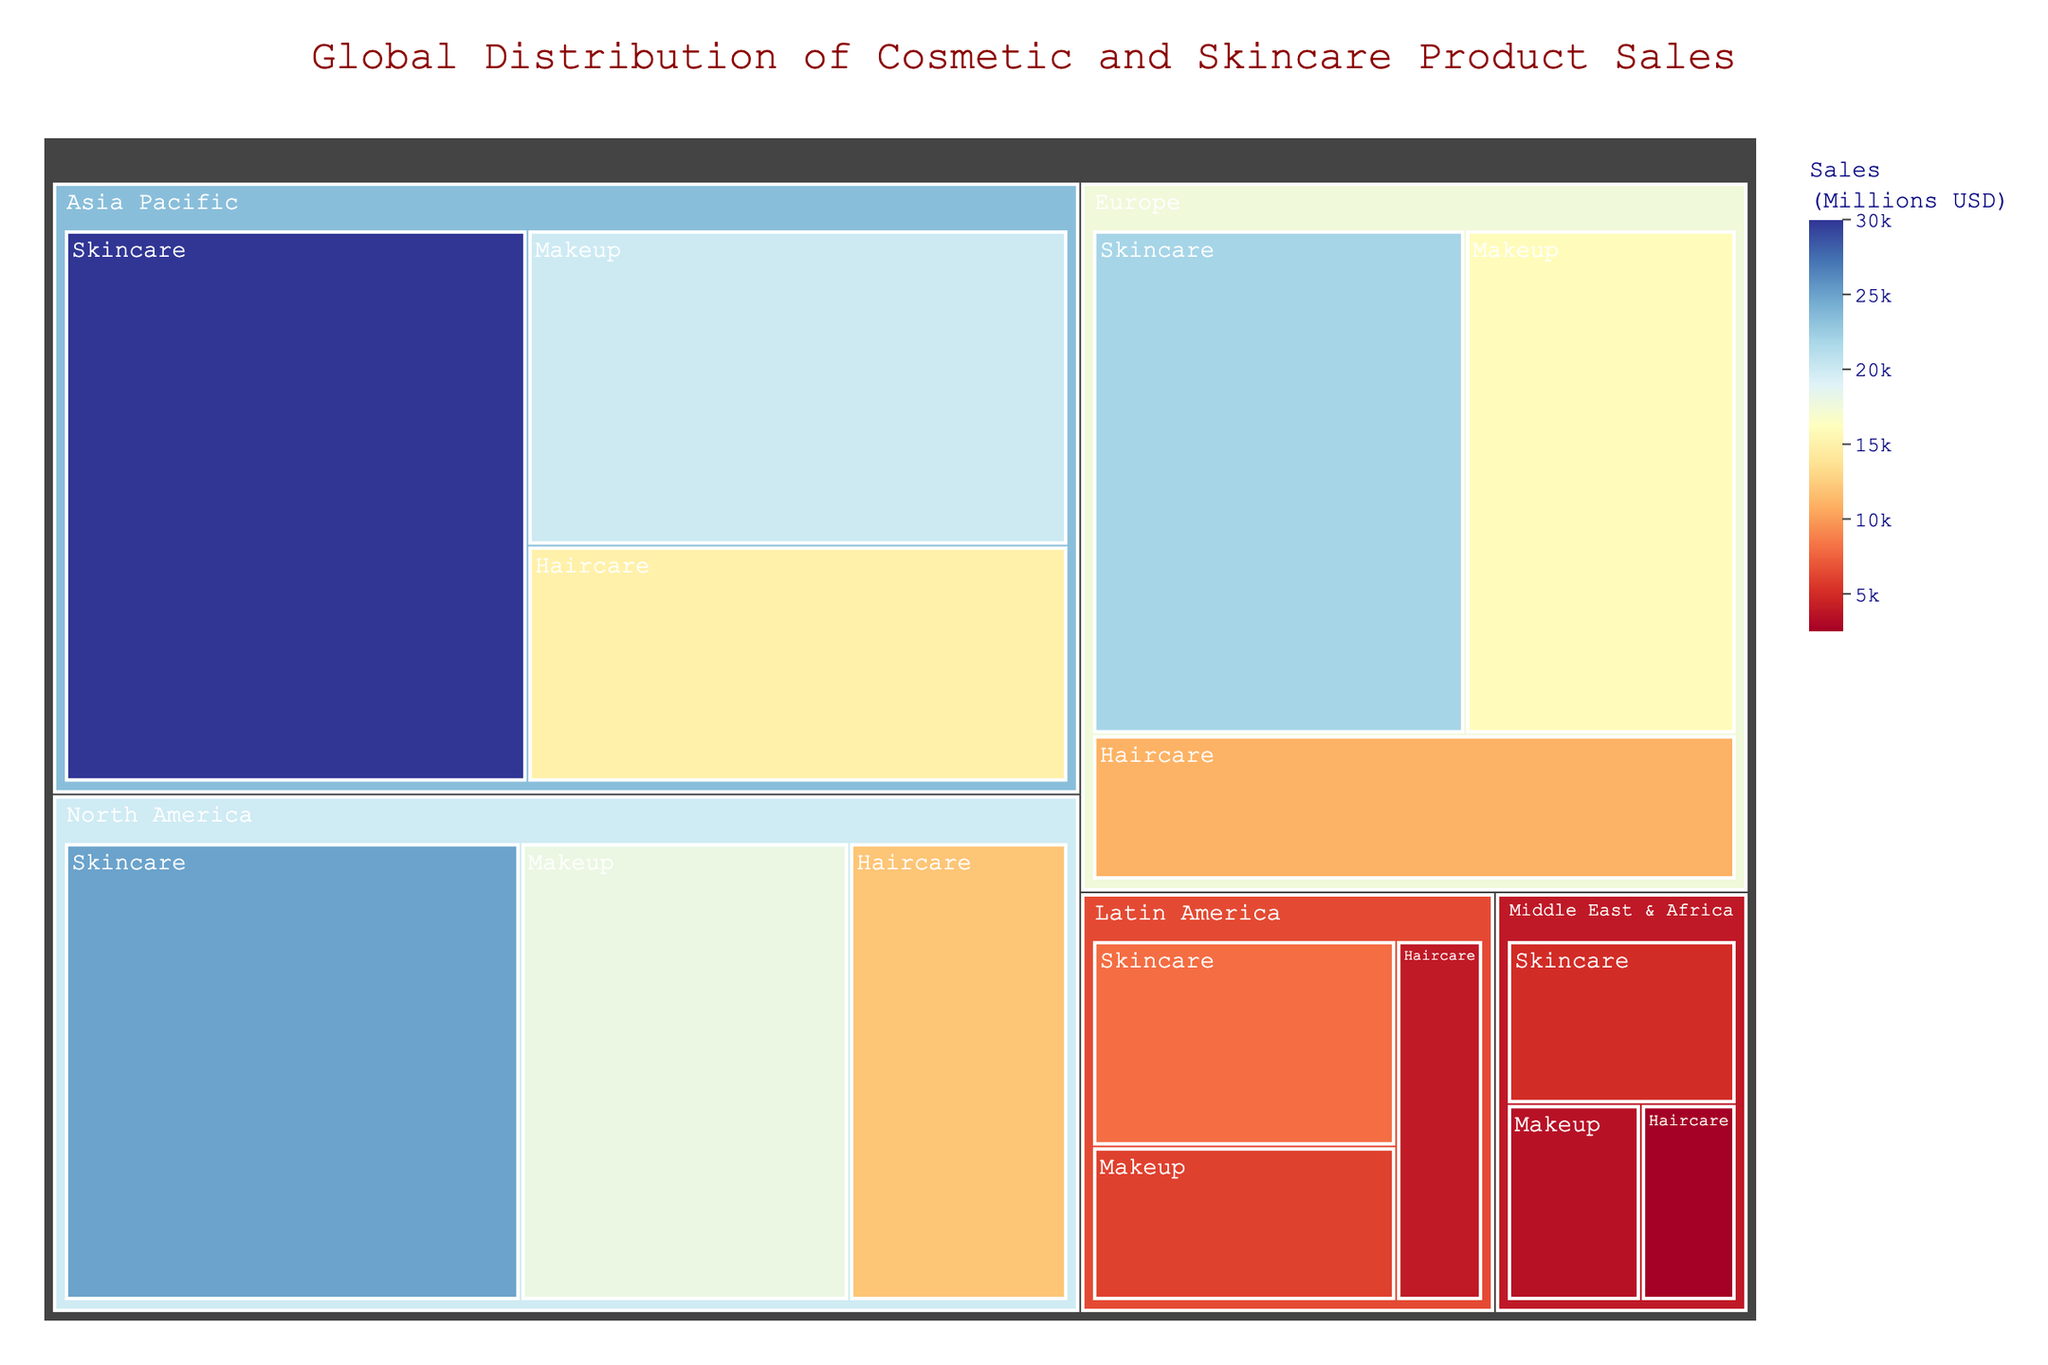Which product type has the highest sales in North America? By examining the treemap, locate the region for "North America" and then identify the product type with the largest proportion. "Skincare" occupies the largest portion, indicating it has the highest sales in North America.
Answer: Skincare What is the total sales of skincare products in Asia Pacific and Europe combined? Identify the sales for "Skincare" in both "Asia Pacific" and "Europe" regions. Sum these values: $30,000 million + $22,000 million.
Answer: $52,000 million Which region has the smallest sales in the "Haircare" product type? Locate the regions for "Haircare" in the treemap and compare their sizes. "Middle East & Africa" has the smallest portion.
Answer: Middle East & Africa Compare the sales of "Makeup" products in North America and Europe. Which one is higher? Identify the "Makeup" sales in both "North America" and "Europe" regions. North America's sales are $18,000 million, while Europe's are $16,000 million. North America has higher sales.
Answer: North America What is the total sales for all product types in Latin America? Sum the sales values for "Skincare," "Makeup," and "Haircare" in the "Latin America" region: $8,000 million + $6,000 million + $4,000 million.
Answer: $18,000 million Which product type has the lowest sales in the Middle East & Africa? By examining the treemap, locate the "Middle East & Africa" section and identify the product type with the smallest proportion. "Haircare" has the smallest portion.
Answer: Haircare Calculate the percentage share of "Skincare" sales in the North America region out of the total North America sales. Find the total sales in North America by summing all product types: $25,000 million + $18,000 million + $12,000 million = $55,000 million. The Skincare sales are $25,000 million. The percentage share is ($25,000 million / $55,000 million) * 100%.
Answer: 45.45% Which region shows the largest difference in sales between "Skincare" and "Haircare" products? Calculate the sales differences between "Skincare" and "Haircare" for each region: 
North America: $25,000 million - $12,000 million = $13,000 million,
Europe: $22,000 million - $11,000 million = $11,000 million,
Asia Pacific: $30,000 million - $15,000 million = $15,000 million,
Latin America: $8,000 million - $4,000 million = $4,000 million,
Middle East & Africa: $5,000 million - $2,500 million = $2,500 million.
The largest difference is in Asia Pacific.
Answer: Asia Pacific What is the total global sales for "Makeup" products across all regions? Sum the sales for "Makeup" in all regions: North America ($18,000 million), Europe ($16,000 million), Asia Pacific ($20,000 million), Latin America ($6,000 million), and Middle East & Africa ($3,500 million). The total is $18,000M + $16,000M + $20,000M + $6,000M + $3,500M = $63,500 million.
Answer: $63,500 million Among "Haircare" products, which two regions have the closest sales figures? Compare the sales of "Haircare" across all regions: North America ($12,000 million), Europe ($11,000 million), Asia Pacific ($15,000 million), Latin America ($4,000 million), and Middle East & Africa ($2,500 million). The closest figures are in North America and Europe, differing by $1,000 million.
Answer: North America and Europe 